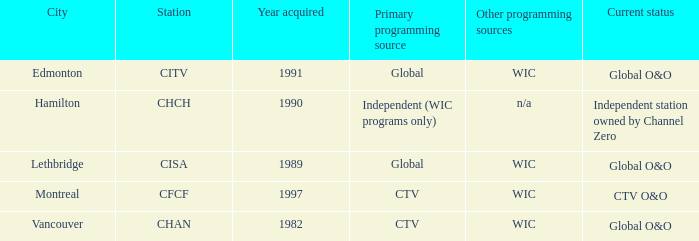Which station is situated in edmonton? CITV. Give me the full table as a dictionary. {'header': ['City', 'Station', 'Year acquired', 'Primary programming source', 'Other programming sources', 'Current status'], 'rows': [['Edmonton', 'CITV', '1991', 'Global', 'WIC', 'Global O&O'], ['Hamilton', 'CHCH', '1990', 'Independent (WIC programs only)', 'n/a', 'Independent station owned by Channel Zero'], ['Lethbridge', 'CISA', '1989', 'Global', 'WIC', 'Global O&O'], ['Montreal', 'CFCF', '1997', 'CTV', 'WIC', 'CTV O&O'], ['Vancouver', 'CHAN', '1982', 'CTV', 'WIC', 'Global O&O']]} 